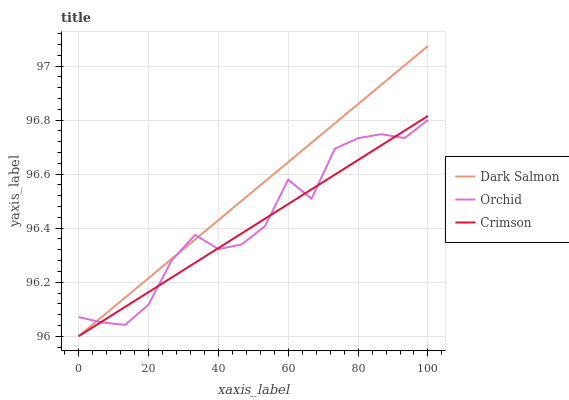Does Crimson have the minimum area under the curve?
Answer yes or no. Yes. Does Dark Salmon have the maximum area under the curve?
Answer yes or no. Yes. Does Orchid have the minimum area under the curve?
Answer yes or no. No. Does Orchid have the maximum area under the curve?
Answer yes or no. No. Is Dark Salmon the smoothest?
Answer yes or no. Yes. Is Orchid the roughest?
Answer yes or no. Yes. Is Orchid the smoothest?
Answer yes or no. No. Is Dark Salmon the roughest?
Answer yes or no. No. Does Crimson have the lowest value?
Answer yes or no. Yes. Does Orchid have the lowest value?
Answer yes or no. No. Does Dark Salmon have the highest value?
Answer yes or no. Yes. Does Orchid have the highest value?
Answer yes or no. No. Does Crimson intersect Dark Salmon?
Answer yes or no. Yes. Is Crimson less than Dark Salmon?
Answer yes or no. No. Is Crimson greater than Dark Salmon?
Answer yes or no. No. 